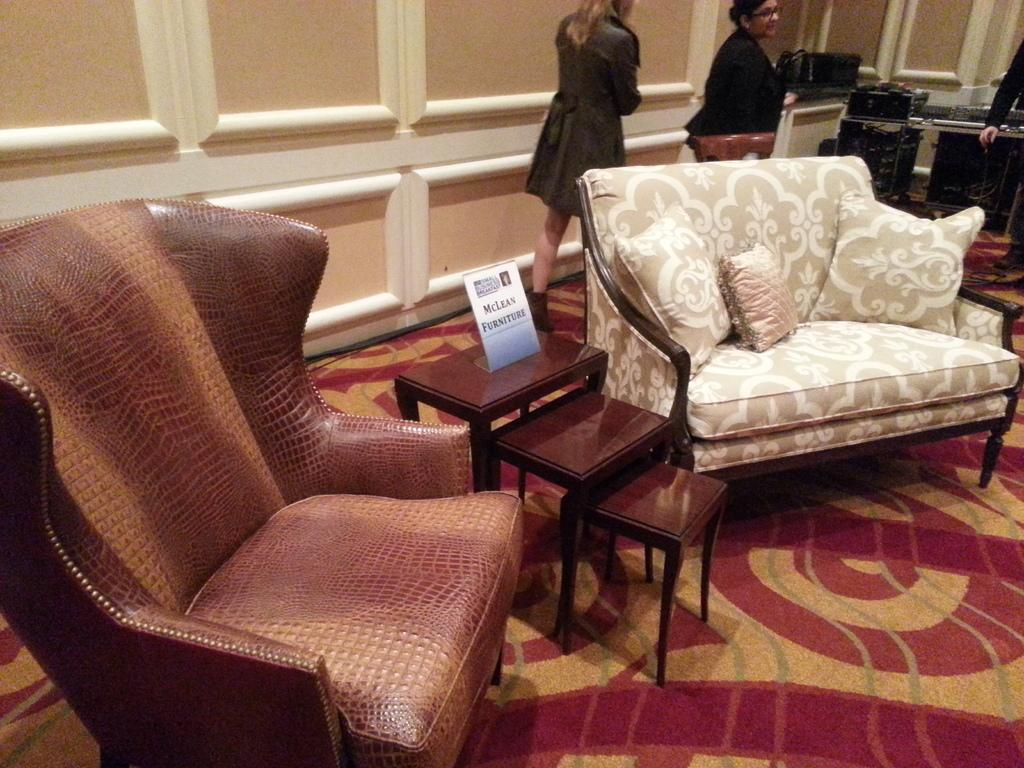How many sofas are in the image? There are two sofas in the image. What is the difference between the two sofas? The sofas are different in color. What is present between the two sofas? There are three tables between the two sofas. Are there any people visible in the image? Yes, there are two persons behind one of the sofas. What type of soup is being served on the tables between the sofas? There is no soup present in the image; the tables are empty. Can you see a hook on the wall behind the sofas? There is no hook visible on the wall behind the sofas in the image. 